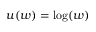Convert formula to latex. <formula><loc_0><loc_0><loc_500><loc_500>u ( w ) = \log ( w )</formula> 